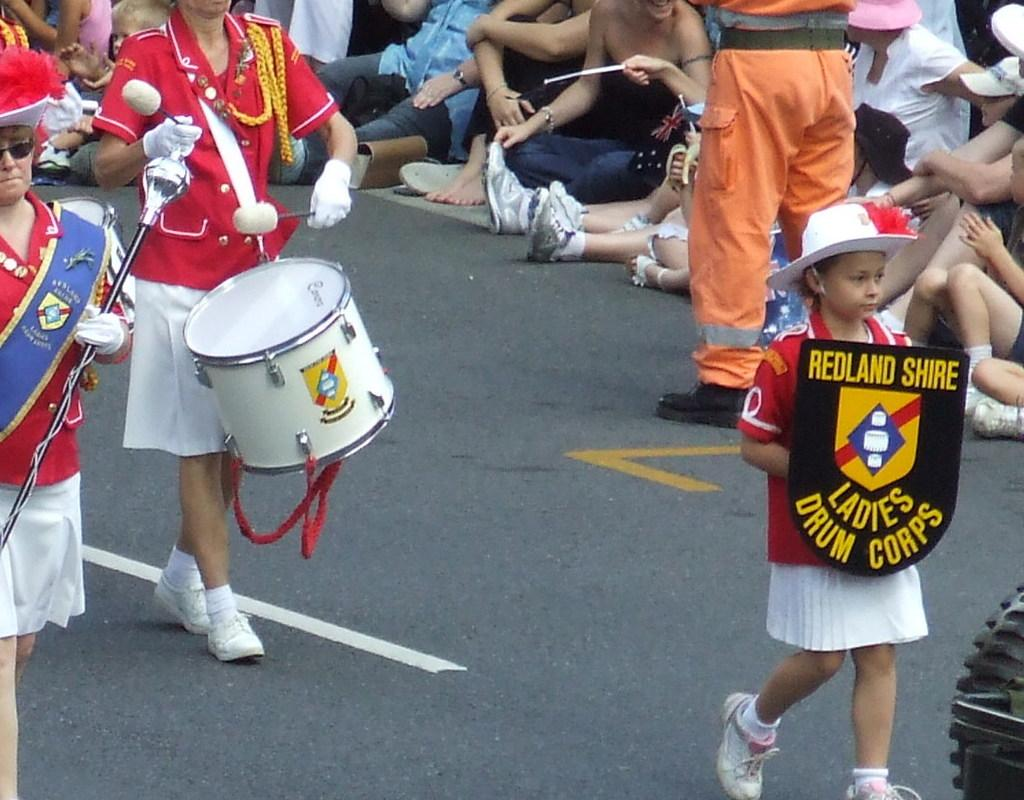<image>
Give a short and clear explanation of the subsequent image. Members of the Redland Shire Ladies Drum Corps are marching down the street. 